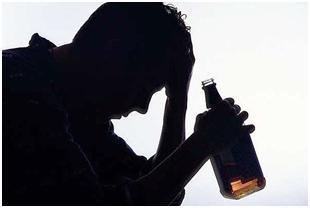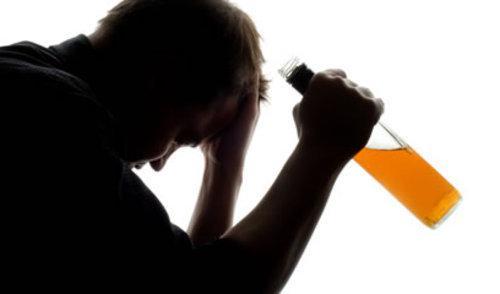The first image is the image on the left, the second image is the image on the right. Analyze the images presented: Is the assertion "In at least one image there is a single male silhouette drink a glass of beer." valid? Answer yes or no. No. 